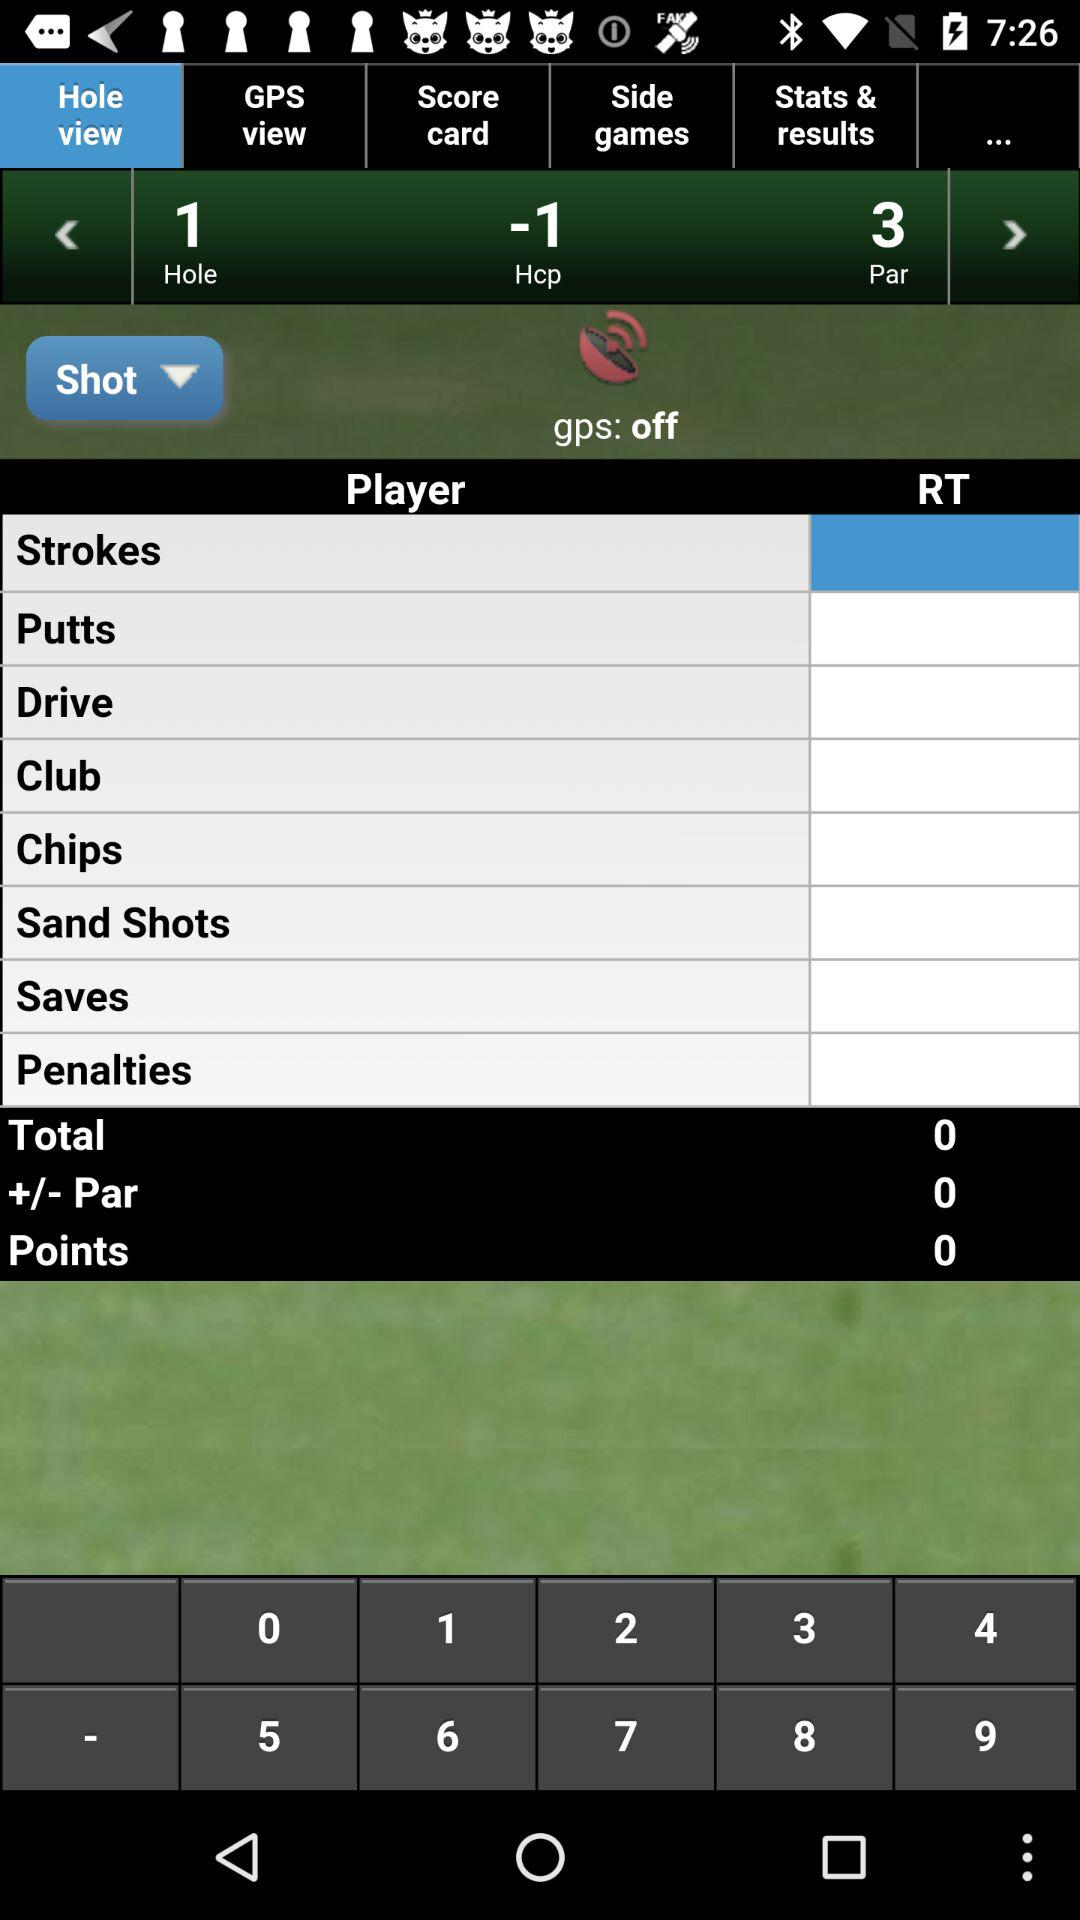What is the number for "Total"? The number for "Total" is 0. 